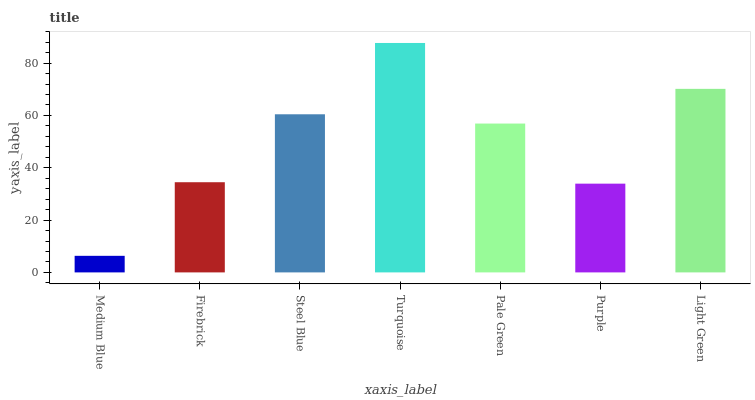Is Medium Blue the minimum?
Answer yes or no. Yes. Is Turquoise the maximum?
Answer yes or no. Yes. Is Firebrick the minimum?
Answer yes or no. No. Is Firebrick the maximum?
Answer yes or no. No. Is Firebrick greater than Medium Blue?
Answer yes or no. Yes. Is Medium Blue less than Firebrick?
Answer yes or no. Yes. Is Medium Blue greater than Firebrick?
Answer yes or no. No. Is Firebrick less than Medium Blue?
Answer yes or no. No. Is Pale Green the high median?
Answer yes or no. Yes. Is Pale Green the low median?
Answer yes or no. Yes. Is Light Green the high median?
Answer yes or no. No. Is Firebrick the low median?
Answer yes or no. No. 